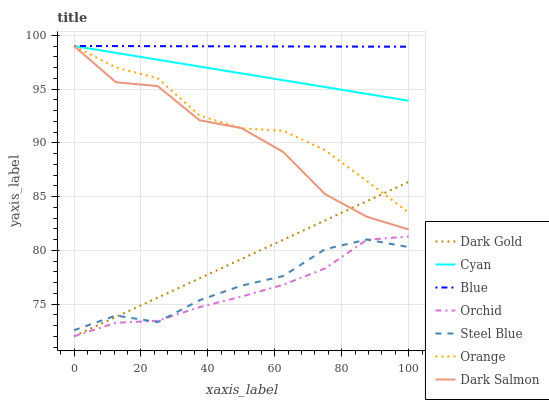Does Orchid have the minimum area under the curve?
Answer yes or no. Yes. Does Blue have the maximum area under the curve?
Answer yes or no. Yes. Does Dark Gold have the minimum area under the curve?
Answer yes or no. No. Does Dark Gold have the maximum area under the curve?
Answer yes or no. No. Is Blue the smoothest?
Answer yes or no. Yes. Is Dark Salmon the roughest?
Answer yes or no. Yes. Is Dark Gold the smoothest?
Answer yes or no. No. Is Dark Gold the roughest?
Answer yes or no. No. Does Steel Blue have the lowest value?
Answer yes or no. No. Does Cyan have the highest value?
Answer yes or no. Yes. Does Dark Gold have the highest value?
Answer yes or no. No. Is Orchid less than Cyan?
Answer yes or no. Yes. Is Orange greater than Orchid?
Answer yes or no. Yes. Does Dark Gold intersect Dark Salmon?
Answer yes or no. Yes. Is Dark Gold less than Dark Salmon?
Answer yes or no. No. Is Dark Gold greater than Dark Salmon?
Answer yes or no. No. Does Orchid intersect Cyan?
Answer yes or no. No. 